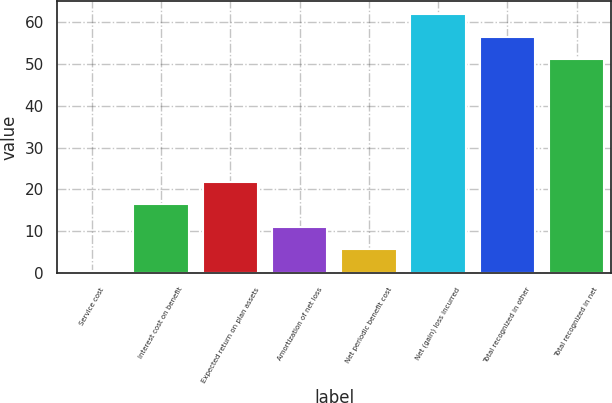Convert chart. <chart><loc_0><loc_0><loc_500><loc_500><bar_chart><fcel>Service cost<fcel>Interest cost on benefit<fcel>Expected return on plan assets<fcel>Amortization of net loss<fcel>Net periodic benefit cost<fcel>Net (gain) loss incurred<fcel>Total recognized in other<fcel>Total recognized in net<nl><fcel>0.4<fcel>16.42<fcel>21.76<fcel>11.08<fcel>5.74<fcel>61.88<fcel>56.54<fcel>51.2<nl></chart> 